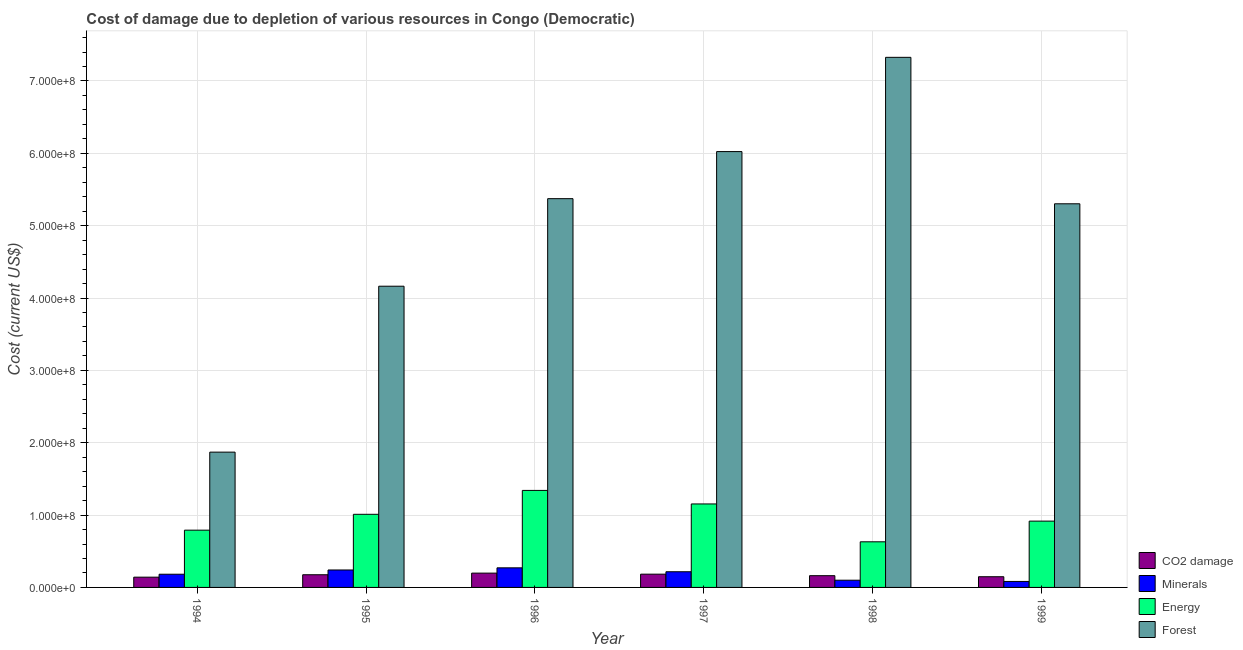How many different coloured bars are there?
Offer a very short reply. 4. Are the number of bars per tick equal to the number of legend labels?
Your response must be concise. Yes. Are the number of bars on each tick of the X-axis equal?
Give a very brief answer. Yes. How many bars are there on the 3rd tick from the left?
Your answer should be very brief. 4. How many bars are there on the 6th tick from the right?
Your response must be concise. 4. In how many cases, is the number of bars for a given year not equal to the number of legend labels?
Ensure brevity in your answer.  0. What is the cost of damage due to depletion of forests in 1999?
Ensure brevity in your answer.  5.30e+08. Across all years, what is the maximum cost of damage due to depletion of energy?
Make the answer very short. 1.34e+08. Across all years, what is the minimum cost of damage due to depletion of forests?
Your response must be concise. 1.87e+08. In which year was the cost of damage due to depletion of minerals maximum?
Ensure brevity in your answer.  1996. What is the total cost of damage due to depletion of minerals in the graph?
Your answer should be compact. 1.09e+08. What is the difference between the cost of damage due to depletion of minerals in 1996 and that in 1999?
Offer a terse response. 1.88e+07. What is the difference between the cost of damage due to depletion of coal in 1995 and the cost of damage due to depletion of energy in 1994?
Ensure brevity in your answer.  3.35e+06. What is the average cost of damage due to depletion of forests per year?
Offer a terse response. 5.01e+08. In how many years, is the cost of damage due to depletion of forests greater than 680000000 US$?
Give a very brief answer. 1. What is the ratio of the cost of damage due to depletion of coal in 1997 to that in 1999?
Offer a very short reply. 1.24. Is the cost of damage due to depletion of forests in 1994 less than that in 1995?
Keep it short and to the point. Yes. What is the difference between the highest and the second highest cost of damage due to depletion of minerals?
Make the answer very short. 2.97e+06. What is the difference between the highest and the lowest cost of damage due to depletion of minerals?
Give a very brief answer. 1.88e+07. In how many years, is the cost of damage due to depletion of energy greater than the average cost of damage due to depletion of energy taken over all years?
Ensure brevity in your answer.  3. What does the 3rd bar from the left in 1996 represents?
Offer a terse response. Energy. What does the 4th bar from the right in 1995 represents?
Give a very brief answer. CO2 damage. Where does the legend appear in the graph?
Make the answer very short. Bottom right. What is the title of the graph?
Give a very brief answer. Cost of damage due to depletion of various resources in Congo (Democratic) . Does "PFC gas" appear as one of the legend labels in the graph?
Keep it short and to the point. No. What is the label or title of the Y-axis?
Provide a succinct answer. Cost (current US$). What is the Cost (current US$) in CO2 damage in 1994?
Provide a short and direct response. 1.42e+07. What is the Cost (current US$) in Minerals in 1994?
Provide a succinct answer. 1.82e+07. What is the Cost (current US$) of Energy in 1994?
Give a very brief answer. 7.91e+07. What is the Cost (current US$) of Forest in 1994?
Provide a succinct answer. 1.87e+08. What is the Cost (current US$) of CO2 damage in 1995?
Your response must be concise. 1.75e+07. What is the Cost (current US$) in Minerals in 1995?
Provide a short and direct response. 2.41e+07. What is the Cost (current US$) of Energy in 1995?
Your answer should be very brief. 1.01e+08. What is the Cost (current US$) in Forest in 1995?
Keep it short and to the point. 4.16e+08. What is the Cost (current US$) of CO2 damage in 1996?
Give a very brief answer. 1.98e+07. What is the Cost (current US$) in Minerals in 1996?
Give a very brief answer. 2.71e+07. What is the Cost (current US$) of Energy in 1996?
Give a very brief answer. 1.34e+08. What is the Cost (current US$) of Forest in 1996?
Make the answer very short. 5.37e+08. What is the Cost (current US$) of CO2 damage in 1997?
Give a very brief answer. 1.83e+07. What is the Cost (current US$) in Minerals in 1997?
Provide a short and direct response. 2.17e+07. What is the Cost (current US$) of Energy in 1997?
Offer a very short reply. 1.15e+08. What is the Cost (current US$) in Forest in 1997?
Ensure brevity in your answer.  6.02e+08. What is the Cost (current US$) in CO2 damage in 1998?
Offer a terse response. 1.62e+07. What is the Cost (current US$) in Minerals in 1998?
Make the answer very short. 9.97e+06. What is the Cost (current US$) of Energy in 1998?
Your answer should be very brief. 6.31e+07. What is the Cost (current US$) in Forest in 1998?
Your answer should be very brief. 7.33e+08. What is the Cost (current US$) in CO2 damage in 1999?
Give a very brief answer. 1.48e+07. What is the Cost (current US$) of Minerals in 1999?
Offer a very short reply. 8.26e+06. What is the Cost (current US$) in Energy in 1999?
Give a very brief answer. 9.16e+07. What is the Cost (current US$) of Forest in 1999?
Keep it short and to the point. 5.30e+08. Across all years, what is the maximum Cost (current US$) in CO2 damage?
Your response must be concise. 1.98e+07. Across all years, what is the maximum Cost (current US$) in Minerals?
Your response must be concise. 2.71e+07. Across all years, what is the maximum Cost (current US$) of Energy?
Give a very brief answer. 1.34e+08. Across all years, what is the maximum Cost (current US$) of Forest?
Your answer should be very brief. 7.33e+08. Across all years, what is the minimum Cost (current US$) in CO2 damage?
Offer a very short reply. 1.42e+07. Across all years, what is the minimum Cost (current US$) in Minerals?
Offer a terse response. 8.26e+06. Across all years, what is the minimum Cost (current US$) of Energy?
Keep it short and to the point. 6.31e+07. Across all years, what is the minimum Cost (current US$) in Forest?
Provide a short and direct response. 1.87e+08. What is the total Cost (current US$) of CO2 damage in the graph?
Provide a short and direct response. 1.01e+08. What is the total Cost (current US$) in Minerals in the graph?
Keep it short and to the point. 1.09e+08. What is the total Cost (current US$) of Energy in the graph?
Make the answer very short. 5.84e+08. What is the total Cost (current US$) of Forest in the graph?
Provide a succinct answer. 3.01e+09. What is the difference between the Cost (current US$) in CO2 damage in 1994 and that in 1995?
Give a very brief answer. -3.35e+06. What is the difference between the Cost (current US$) of Minerals in 1994 and that in 1995?
Your answer should be compact. -5.87e+06. What is the difference between the Cost (current US$) of Energy in 1994 and that in 1995?
Provide a succinct answer. -2.19e+07. What is the difference between the Cost (current US$) of Forest in 1994 and that in 1995?
Provide a short and direct response. -2.29e+08. What is the difference between the Cost (current US$) in CO2 damage in 1994 and that in 1996?
Provide a short and direct response. -5.60e+06. What is the difference between the Cost (current US$) of Minerals in 1994 and that in 1996?
Offer a very short reply. -8.84e+06. What is the difference between the Cost (current US$) in Energy in 1994 and that in 1996?
Your answer should be compact. -5.49e+07. What is the difference between the Cost (current US$) of Forest in 1994 and that in 1996?
Keep it short and to the point. -3.50e+08. What is the difference between the Cost (current US$) of CO2 damage in 1994 and that in 1997?
Ensure brevity in your answer.  -4.15e+06. What is the difference between the Cost (current US$) of Minerals in 1994 and that in 1997?
Your response must be concise. -3.42e+06. What is the difference between the Cost (current US$) of Energy in 1994 and that in 1997?
Your response must be concise. -3.62e+07. What is the difference between the Cost (current US$) of Forest in 1994 and that in 1997?
Provide a short and direct response. -4.15e+08. What is the difference between the Cost (current US$) in CO2 damage in 1994 and that in 1998?
Make the answer very short. -2.05e+06. What is the difference between the Cost (current US$) in Minerals in 1994 and that in 1998?
Provide a succinct answer. 8.28e+06. What is the difference between the Cost (current US$) of Energy in 1994 and that in 1998?
Keep it short and to the point. 1.61e+07. What is the difference between the Cost (current US$) of Forest in 1994 and that in 1998?
Ensure brevity in your answer.  -5.46e+08. What is the difference between the Cost (current US$) of CO2 damage in 1994 and that in 1999?
Offer a very short reply. -6.12e+05. What is the difference between the Cost (current US$) in Minerals in 1994 and that in 1999?
Keep it short and to the point. 9.99e+06. What is the difference between the Cost (current US$) of Energy in 1994 and that in 1999?
Provide a short and direct response. -1.25e+07. What is the difference between the Cost (current US$) of Forest in 1994 and that in 1999?
Provide a succinct answer. -3.43e+08. What is the difference between the Cost (current US$) of CO2 damage in 1995 and that in 1996?
Offer a terse response. -2.25e+06. What is the difference between the Cost (current US$) in Minerals in 1995 and that in 1996?
Provide a short and direct response. -2.97e+06. What is the difference between the Cost (current US$) of Energy in 1995 and that in 1996?
Make the answer very short. -3.30e+07. What is the difference between the Cost (current US$) of Forest in 1995 and that in 1996?
Offer a terse response. -1.21e+08. What is the difference between the Cost (current US$) in CO2 damage in 1995 and that in 1997?
Offer a terse response. -8.02e+05. What is the difference between the Cost (current US$) of Minerals in 1995 and that in 1997?
Offer a very short reply. 2.44e+06. What is the difference between the Cost (current US$) in Energy in 1995 and that in 1997?
Give a very brief answer. -1.43e+07. What is the difference between the Cost (current US$) of Forest in 1995 and that in 1997?
Provide a succinct answer. -1.86e+08. What is the difference between the Cost (current US$) in CO2 damage in 1995 and that in 1998?
Give a very brief answer. 1.30e+06. What is the difference between the Cost (current US$) in Minerals in 1995 and that in 1998?
Offer a very short reply. 1.41e+07. What is the difference between the Cost (current US$) in Energy in 1995 and that in 1998?
Your answer should be compact. 3.80e+07. What is the difference between the Cost (current US$) in Forest in 1995 and that in 1998?
Your answer should be compact. -3.16e+08. What is the difference between the Cost (current US$) of CO2 damage in 1995 and that in 1999?
Make the answer very short. 2.74e+06. What is the difference between the Cost (current US$) in Minerals in 1995 and that in 1999?
Your answer should be very brief. 1.59e+07. What is the difference between the Cost (current US$) in Energy in 1995 and that in 1999?
Offer a very short reply. 9.42e+06. What is the difference between the Cost (current US$) in Forest in 1995 and that in 1999?
Your answer should be compact. -1.14e+08. What is the difference between the Cost (current US$) of CO2 damage in 1996 and that in 1997?
Make the answer very short. 1.45e+06. What is the difference between the Cost (current US$) in Minerals in 1996 and that in 1997?
Ensure brevity in your answer.  5.42e+06. What is the difference between the Cost (current US$) of Energy in 1996 and that in 1997?
Keep it short and to the point. 1.87e+07. What is the difference between the Cost (current US$) in Forest in 1996 and that in 1997?
Your response must be concise. -6.51e+07. What is the difference between the Cost (current US$) in CO2 damage in 1996 and that in 1998?
Provide a short and direct response. 3.54e+06. What is the difference between the Cost (current US$) of Minerals in 1996 and that in 1998?
Your answer should be very brief. 1.71e+07. What is the difference between the Cost (current US$) in Energy in 1996 and that in 1998?
Keep it short and to the point. 7.10e+07. What is the difference between the Cost (current US$) of Forest in 1996 and that in 1998?
Provide a succinct answer. -1.95e+08. What is the difference between the Cost (current US$) in CO2 damage in 1996 and that in 1999?
Your answer should be very brief. 4.98e+06. What is the difference between the Cost (current US$) in Minerals in 1996 and that in 1999?
Give a very brief answer. 1.88e+07. What is the difference between the Cost (current US$) of Energy in 1996 and that in 1999?
Ensure brevity in your answer.  4.24e+07. What is the difference between the Cost (current US$) in Forest in 1996 and that in 1999?
Your response must be concise. 7.09e+06. What is the difference between the Cost (current US$) of CO2 damage in 1997 and that in 1998?
Ensure brevity in your answer.  2.10e+06. What is the difference between the Cost (current US$) of Minerals in 1997 and that in 1998?
Provide a short and direct response. 1.17e+07. What is the difference between the Cost (current US$) in Energy in 1997 and that in 1998?
Keep it short and to the point. 5.23e+07. What is the difference between the Cost (current US$) in Forest in 1997 and that in 1998?
Your answer should be very brief. -1.30e+08. What is the difference between the Cost (current US$) in CO2 damage in 1997 and that in 1999?
Ensure brevity in your answer.  3.54e+06. What is the difference between the Cost (current US$) of Minerals in 1997 and that in 1999?
Keep it short and to the point. 1.34e+07. What is the difference between the Cost (current US$) in Energy in 1997 and that in 1999?
Your response must be concise. 2.38e+07. What is the difference between the Cost (current US$) of Forest in 1997 and that in 1999?
Ensure brevity in your answer.  7.22e+07. What is the difference between the Cost (current US$) in CO2 damage in 1998 and that in 1999?
Make the answer very short. 1.44e+06. What is the difference between the Cost (current US$) of Minerals in 1998 and that in 1999?
Offer a terse response. 1.71e+06. What is the difference between the Cost (current US$) in Energy in 1998 and that in 1999?
Provide a succinct answer. -2.86e+07. What is the difference between the Cost (current US$) of Forest in 1998 and that in 1999?
Provide a short and direct response. 2.02e+08. What is the difference between the Cost (current US$) of CO2 damage in 1994 and the Cost (current US$) of Minerals in 1995?
Provide a succinct answer. -9.93e+06. What is the difference between the Cost (current US$) of CO2 damage in 1994 and the Cost (current US$) of Energy in 1995?
Offer a very short reply. -8.69e+07. What is the difference between the Cost (current US$) in CO2 damage in 1994 and the Cost (current US$) in Forest in 1995?
Your answer should be compact. -4.02e+08. What is the difference between the Cost (current US$) of Minerals in 1994 and the Cost (current US$) of Energy in 1995?
Offer a terse response. -8.28e+07. What is the difference between the Cost (current US$) in Minerals in 1994 and the Cost (current US$) in Forest in 1995?
Make the answer very short. -3.98e+08. What is the difference between the Cost (current US$) of Energy in 1994 and the Cost (current US$) of Forest in 1995?
Give a very brief answer. -3.37e+08. What is the difference between the Cost (current US$) of CO2 damage in 1994 and the Cost (current US$) of Minerals in 1996?
Your answer should be compact. -1.29e+07. What is the difference between the Cost (current US$) of CO2 damage in 1994 and the Cost (current US$) of Energy in 1996?
Provide a succinct answer. -1.20e+08. What is the difference between the Cost (current US$) in CO2 damage in 1994 and the Cost (current US$) in Forest in 1996?
Your response must be concise. -5.23e+08. What is the difference between the Cost (current US$) of Minerals in 1994 and the Cost (current US$) of Energy in 1996?
Keep it short and to the point. -1.16e+08. What is the difference between the Cost (current US$) of Minerals in 1994 and the Cost (current US$) of Forest in 1996?
Your answer should be compact. -5.19e+08. What is the difference between the Cost (current US$) in Energy in 1994 and the Cost (current US$) in Forest in 1996?
Your answer should be very brief. -4.58e+08. What is the difference between the Cost (current US$) of CO2 damage in 1994 and the Cost (current US$) of Minerals in 1997?
Provide a short and direct response. -7.49e+06. What is the difference between the Cost (current US$) of CO2 damage in 1994 and the Cost (current US$) of Energy in 1997?
Your answer should be very brief. -1.01e+08. What is the difference between the Cost (current US$) in CO2 damage in 1994 and the Cost (current US$) in Forest in 1997?
Make the answer very short. -5.88e+08. What is the difference between the Cost (current US$) in Minerals in 1994 and the Cost (current US$) in Energy in 1997?
Offer a terse response. -9.71e+07. What is the difference between the Cost (current US$) in Minerals in 1994 and the Cost (current US$) in Forest in 1997?
Ensure brevity in your answer.  -5.84e+08. What is the difference between the Cost (current US$) in Energy in 1994 and the Cost (current US$) in Forest in 1997?
Provide a succinct answer. -5.23e+08. What is the difference between the Cost (current US$) of CO2 damage in 1994 and the Cost (current US$) of Minerals in 1998?
Make the answer very short. 4.22e+06. What is the difference between the Cost (current US$) in CO2 damage in 1994 and the Cost (current US$) in Energy in 1998?
Ensure brevity in your answer.  -4.89e+07. What is the difference between the Cost (current US$) of CO2 damage in 1994 and the Cost (current US$) of Forest in 1998?
Offer a very short reply. -7.19e+08. What is the difference between the Cost (current US$) of Minerals in 1994 and the Cost (current US$) of Energy in 1998?
Keep it short and to the point. -4.48e+07. What is the difference between the Cost (current US$) of Minerals in 1994 and the Cost (current US$) of Forest in 1998?
Ensure brevity in your answer.  -7.14e+08. What is the difference between the Cost (current US$) in Energy in 1994 and the Cost (current US$) in Forest in 1998?
Provide a succinct answer. -6.54e+08. What is the difference between the Cost (current US$) in CO2 damage in 1994 and the Cost (current US$) in Minerals in 1999?
Offer a terse response. 5.92e+06. What is the difference between the Cost (current US$) in CO2 damage in 1994 and the Cost (current US$) in Energy in 1999?
Ensure brevity in your answer.  -7.75e+07. What is the difference between the Cost (current US$) in CO2 damage in 1994 and the Cost (current US$) in Forest in 1999?
Your response must be concise. -5.16e+08. What is the difference between the Cost (current US$) of Minerals in 1994 and the Cost (current US$) of Energy in 1999?
Provide a short and direct response. -7.34e+07. What is the difference between the Cost (current US$) in Minerals in 1994 and the Cost (current US$) in Forest in 1999?
Your response must be concise. -5.12e+08. What is the difference between the Cost (current US$) of Energy in 1994 and the Cost (current US$) of Forest in 1999?
Make the answer very short. -4.51e+08. What is the difference between the Cost (current US$) of CO2 damage in 1995 and the Cost (current US$) of Minerals in 1996?
Your answer should be compact. -9.56e+06. What is the difference between the Cost (current US$) of CO2 damage in 1995 and the Cost (current US$) of Energy in 1996?
Provide a succinct answer. -1.17e+08. What is the difference between the Cost (current US$) in CO2 damage in 1995 and the Cost (current US$) in Forest in 1996?
Offer a very short reply. -5.20e+08. What is the difference between the Cost (current US$) in Minerals in 1995 and the Cost (current US$) in Energy in 1996?
Your answer should be very brief. -1.10e+08. What is the difference between the Cost (current US$) in Minerals in 1995 and the Cost (current US$) in Forest in 1996?
Offer a very short reply. -5.13e+08. What is the difference between the Cost (current US$) in Energy in 1995 and the Cost (current US$) in Forest in 1996?
Keep it short and to the point. -4.36e+08. What is the difference between the Cost (current US$) of CO2 damage in 1995 and the Cost (current US$) of Minerals in 1997?
Your response must be concise. -4.14e+06. What is the difference between the Cost (current US$) in CO2 damage in 1995 and the Cost (current US$) in Energy in 1997?
Give a very brief answer. -9.79e+07. What is the difference between the Cost (current US$) of CO2 damage in 1995 and the Cost (current US$) of Forest in 1997?
Offer a very short reply. -5.85e+08. What is the difference between the Cost (current US$) in Minerals in 1995 and the Cost (current US$) in Energy in 1997?
Keep it short and to the point. -9.13e+07. What is the difference between the Cost (current US$) in Minerals in 1995 and the Cost (current US$) in Forest in 1997?
Give a very brief answer. -5.78e+08. What is the difference between the Cost (current US$) in Energy in 1995 and the Cost (current US$) in Forest in 1997?
Keep it short and to the point. -5.01e+08. What is the difference between the Cost (current US$) of CO2 damage in 1995 and the Cost (current US$) of Minerals in 1998?
Your answer should be compact. 7.56e+06. What is the difference between the Cost (current US$) in CO2 damage in 1995 and the Cost (current US$) in Energy in 1998?
Provide a short and direct response. -4.55e+07. What is the difference between the Cost (current US$) of CO2 damage in 1995 and the Cost (current US$) of Forest in 1998?
Your response must be concise. -7.15e+08. What is the difference between the Cost (current US$) in Minerals in 1995 and the Cost (current US$) in Energy in 1998?
Make the answer very short. -3.89e+07. What is the difference between the Cost (current US$) in Minerals in 1995 and the Cost (current US$) in Forest in 1998?
Your answer should be compact. -7.09e+08. What is the difference between the Cost (current US$) of Energy in 1995 and the Cost (current US$) of Forest in 1998?
Provide a short and direct response. -6.32e+08. What is the difference between the Cost (current US$) of CO2 damage in 1995 and the Cost (current US$) of Minerals in 1999?
Give a very brief answer. 9.27e+06. What is the difference between the Cost (current US$) of CO2 damage in 1995 and the Cost (current US$) of Energy in 1999?
Give a very brief answer. -7.41e+07. What is the difference between the Cost (current US$) in CO2 damage in 1995 and the Cost (current US$) in Forest in 1999?
Give a very brief answer. -5.13e+08. What is the difference between the Cost (current US$) of Minerals in 1995 and the Cost (current US$) of Energy in 1999?
Provide a short and direct response. -6.75e+07. What is the difference between the Cost (current US$) of Minerals in 1995 and the Cost (current US$) of Forest in 1999?
Ensure brevity in your answer.  -5.06e+08. What is the difference between the Cost (current US$) in Energy in 1995 and the Cost (current US$) in Forest in 1999?
Your answer should be very brief. -4.29e+08. What is the difference between the Cost (current US$) of CO2 damage in 1996 and the Cost (current US$) of Minerals in 1997?
Provide a succinct answer. -1.89e+06. What is the difference between the Cost (current US$) of CO2 damage in 1996 and the Cost (current US$) of Energy in 1997?
Ensure brevity in your answer.  -9.56e+07. What is the difference between the Cost (current US$) in CO2 damage in 1996 and the Cost (current US$) in Forest in 1997?
Offer a very short reply. -5.83e+08. What is the difference between the Cost (current US$) in Minerals in 1996 and the Cost (current US$) in Energy in 1997?
Provide a succinct answer. -8.83e+07. What is the difference between the Cost (current US$) in Minerals in 1996 and the Cost (current US$) in Forest in 1997?
Offer a very short reply. -5.75e+08. What is the difference between the Cost (current US$) of Energy in 1996 and the Cost (current US$) of Forest in 1997?
Provide a succinct answer. -4.68e+08. What is the difference between the Cost (current US$) of CO2 damage in 1996 and the Cost (current US$) of Minerals in 1998?
Give a very brief answer. 9.81e+06. What is the difference between the Cost (current US$) of CO2 damage in 1996 and the Cost (current US$) of Energy in 1998?
Provide a succinct answer. -4.33e+07. What is the difference between the Cost (current US$) in CO2 damage in 1996 and the Cost (current US$) in Forest in 1998?
Your answer should be very brief. -7.13e+08. What is the difference between the Cost (current US$) in Minerals in 1996 and the Cost (current US$) in Energy in 1998?
Ensure brevity in your answer.  -3.60e+07. What is the difference between the Cost (current US$) of Minerals in 1996 and the Cost (current US$) of Forest in 1998?
Offer a terse response. -7.06e+08. What is the difference between the Cost (current US$) of Energy in 1996 and the Cost (current US$) of Forest in 1998?
Provide a succinct answer. -5.99e+08. What is the difference between the Cost (current US$) of CO2 damage in 1996 and the Cost (current US$) of Minerals in 1999?
Your answer should be compact. 1.15e+07. What is the difference between the Cost (current US$) in CO2 damage in 1996 and the Cost (current US$) in Energy in 1999?
Your answer should be very brief. -7.19e+07. What is the difference between the Cost (current US$) in CO2 damage in 1996 and the Cost (current US$) in Forest in 1999?
Make the answer very short. -5.10e+08. What is the difference between the Cost (current US$) in Minerals in 1996 and the Cost (current US$) in Energy in 1999?
Make the answer very short. -6.46e+07. What is the difference between the Cost (current US$) in Minerals in 1996 and the Cost (current US$) in Forest in 1999?
Give a very brief answer. -5.03e+08. What is the difference between the Cost (current US$) of Energy in 1996 and the Cost (current US$) of Forest in 1999?
Provide a short and direct response. -3.96e+08. What is the difference between the Cost (current US$) in CO2 damage in 1997 and the Cost (current US$) in Minerals in 1998?
Ensure brevity in your answer.  8.37e+06. What is the difference between the Cost (current US$) of CO2 damage in 1997 and the Cost (current US$) of Energy in 1998?
Your answer should be compact. -4.47e+07. What is the difference between the Cost (current US$) in CO2 damage in 1997 and the Cost (current US$) in Forest in 1998?
Keep it short and to the point. -7.14e+08. What is the difference between the Cost (current US$) of Minerals in 1997 and the Cost (current US$) of Energy in 1998?
Give a very brief answer. -4.14e+07. What is the difference between the Cost (current US$) of Minerals in 1997 and the Cost (current US$) of Forest in 1998?
Provide a short and direct response. -7.11e+08. What is the difference between the Cost (current US$) in Energy in 1997 and the Cost (current US$) in Forest in 1998?
Provide a short and direct response. -6.17e+08. What is the difference between the Cost (current US$) in CO2 damage in 1997 and the Cost (current US$) in Minerals in 1999?
Offer a terse response. 1.01e+07. What is the difference between the Cost (current US$) in CO2 damage in 1997 and the Cost (current US$) in Energy in 1999?
Keep it short and to the point. -7.33e+07. What is the difference between the Cost (current US$) of CO2 damage in 1997 and the Cost (current US$) of Forest in 1999?
Your answer should be compact. -5.12e+08. What is the difference between the Cost (current US$) of Minerals in 1997 and the Cost (current US$) of Energy in 1999?
Provide a succinct answer. -7.00e+07. What is the difference between the Cost (current US$) of Minerals in 1997 and the Cost (current US$) of Forest in 1999?
Keep it short and to the point. -5.09e+08. What is the difference between the Cost (current US$) in Energy in 1997 and the Cost (current US$) in Forest in 1999?
Offer a very short reply. -4.15e+08. What is the difference between the Cost (current US$) of CO2 damage in 1998 and the Cost (current US$) of Minerals in 1999?
Your response must be concise. 7.97e+06. What is the difference between the Cost (current US$) of CO2 damage in 1998 and the Cost (current US$) of Energy in 1999?
Your response must be concise. -7.54e+07. What is the difference between the Cost (current US$) of CO2 damage in 1998 and the Cost (current US$) of Forest in 1999?
Provide a succinct answer. -5.14e+08. What is the difference between the Cost (current US$) in Minerals in 1998 and the Cost (current US$) in Energy in 1999?
Your response must be concise. -8.17e+07. What is the difference between the Cost (current US$) in Minerals in 1998 and the Cost (current US$) in Forest in 1999?
Provide a succinct answer. -5.20e+08. What is the difference between the Cost (current US$) in Energy in 1998 and the Cost (current US$) in Forest in 1999?
Provide a succinct answer. -4.67e+08. What is the average Cost (current US$) of CO2 damage per year?
Your response must be concise. 1.68e+07. What is the average Cost (current US$) of Minerals per year?
Offer a terse response. 1.82e+07. What is the average Cost (current US$) in Energy per year?
Give a very brief answer. 9.74e+07. What is the average Cost (current US$) of Forest per year?
Provide a succinct answer. 5.01e+08. In the year 1994, what is the difference between the Cost (current US$) of CO2 damage and Cost (current US$) of Minerals?
Your answer should be compact. -4.06e+06. In the year 1994, what is the difference between the Cost (current US$) of CO2 damage and Cost (current US$) of Energy?
Give a very brief answer. -6.50e+07. In the year 1994, what is the difference between the Cost (current US$) in CO2 damage and Cost (current US$) in Forest?
Offer a very short reply. -1.73e+08. In the year 1994, what is the difference between the Cost (current US$) in Minerals and Cost (current US$) in Energy?
Your answer should be very brief. -6.09e+07. In the year 1994, what is the difference between the Cost (current US$) of Minerals and Cost (current US$) of Forest?
Offer a terse response. -1.69e+08. In the year 1994, what is the difference between the Cost (current US$) in Energy and Cost (current US$) in Forest?
Your answer should be very brief. -1.08e+08. In the year 1995, what is the difference between the Cost (current US$) of CO2 damage and Cost (current US$) of Minerals?
Offer a terse response. -6.58e+06. In the year 1995, what is the difference between the Cost (current US$) of CO2 damage and Cost (current US$) of Energy?
Make the answer very short. -8.35e+07. In the year 1995, what is the difference between the Cost (current US$) of CO2 damage and Cost (current US$) of Forest?
Your answer should be very brief. -3.99e+08. In the year 1995, what is the difference between the Cost (current US$) in Minerals and Cost (current US$) in Energy?
Offer a terse response. -7.70e+07. In the year 1995, what is the difference between the Cost (current US$) in Minerals and Cost (current US$) in Forest?
Ensure brevity in your answer.  -3.92e+08. In the year 1995, what is the difference between the Cost (current US$) of Energy and Cost (current US$) of Forest?
Provide a succinct answer. -3.15e+08. In the year 1996, what is the difference between the Cost (current US$) in CO2 damage and Cost (current US$) in Minerals?
Offer a terse response. -7.31e+06. In the year 1996, what is the difference between the Cost (current US$) of CO2 damage and Cost (current US$) of Energy?
Ensure brevity in your answer.  -1.14e+08. In the year 1996, what is the difference between the Cost (current US$) in CO2 damage and Cost (current US$) in Forest?
Ensure brevity in your answer.  -5.18e+08. In the year 1996, what is the difference between the Cost (current US$) in Minerals and Cost (current US$) in Energy?
Your answer should be very brief. -1.07e+08. In the year 1996, what is the difference between the Cost (current US$) in Minerals and Cost (current US$) in Forest?
Offer a terse response. -5.10e+08. In the year 1996, what is the difference between the Cost (current US$) of Energy and Cost (current US$) of Forest?
Provide a short and direct response. -4.03e+08. In the year 1997, what is the difference between the Cost (current US$) of CO2 damage and Cost (current US$) of Minerals?
Provide a short and direct response. -3.34e+06. In the year 1997, what is the difference between the Cost (current US$) in CO2 damage and Cost (current US$) in Energy?
Make the answer very short. -9.71e+07. In the year 1997, what is the difference between the Cost (current US$) in CO2 damage and Cost (current US$) in Forest?
Offer a very short reply. -5.84e+08. In the year 1997, what is the difference between the Cost (current US$) in Minerals and Cost (current US$) in Energy?
Ensure brevity in your answer.  -9.37e+07. In the year 1997, what is the difference between the Cost (current US$) of Minerals and Cost (current US$) of Forest?
Your answer should be compact. -5.81e+08. In the year 1997, what is the difference between the Cost (current US$) in Energy and Cost (current US$) in Forest?
Provide a short and direct response. -4.87e+08. In the year 1998, what is the difference between the Cost (current US$) of CO2 damage and Cost (current US$) of Minerals?
Provide a succinct answer. 6.27e+06. In the year 1998, what is the difference between the Cost (current US$) in CO2 damage and Cost (current US$) in Energy?
Keep it short and to the point. -4.68e+07. In the year 1998, what is the difference between the Cost (current US$) in CO2 damage and Cost (current US$) in Forest?
Provide a short and direct response. -7.16e+08. In the year 1998, what is the difference between the Cost (current US$) in Minerals and Cost (current US$) in Energy?
Offer a very short reply. -5.31e+07. In the year 1998, what is the difference between the Cost (current US$) in Minerals and Cost (current US$) in Forest?
Provide a short and direct response. -7.23e+08. In the year 1998, what is the difference between the Cost (current US$) of Energy and Cost (current US$) of Forest?
Make the answer very short. -6.70e+08. In the year 1999, what is the difference between the Cost (current US$) in CO2 damage and Cost (current US$) in Minerals?
Offer a terse response. 6.53e+06. In the year 1999, what is the difference between the Cost (current US$) in CO2 damage and Cost (current US$) in Energy?
Ensure brevity in your answer.  -7.68e+07. In the year 1999, what is the difference between the Cost (current US$) in CO2 damage and Cost (current US$) in Forest?
Offer a very short reply. -5.15e+08. In the year 1999, what is the difference between the Cost (current US$) of Minerals and Cost (current US$) of Energy?
Your response must be concise. -8.34e+07. In the year 1999, what is the difference between the Cost (current US$) in Minerals and Cost (current US$) in Forest?
Make the answer very short. -5.22e+08. In the year 1999, what is the difference between the Cost (current US$) of Energy and Cost (current US$) of Forest?
Your response must be concise. -4.39e+08. What is the ratio of the Cost (current US$) of CO2 damage in 1994 to that in 1995?
Provide a succinct answer. 0.81. What is the ratio of the Cost (current US$) of Minerals in 1994 to that in 1995?
Your answer should be very brief. 0.76. What is the ratio of the Cost (current US$) in Energy in 1994 to that in 1995?
Your response must be concise. 0.78. What is the ratio of the Cost (current US$) of Forest in 1994 to that in 1995?
Give a very brief answer. 0.45. What is the ratio of the Cost (current US$) in CO2 damage in 1994 to that in 1996?
Provide a succinct answer. 0.72. What is the ratio of the Cost (current US$) of Minerals in 1994 to that in 1996?
Your answer should be compact. 0.67. What is the ratio of the Cost (current US$) of Energy in 1994 to that in 1996?
Offer a terse response. 0.59. What is the ratio of the Cost (current US$) of Forest in 1994 to that in 1996?
Offer a terse response. 0.35. What is the ratio of the Cost (current US$) in CO2 damage in 1994 to that in 1997?
Make the answer very short. 0.77. What is the ratio of the Cost (current US$) in Minerals in 1994 to that in 1997?
Your answer should be compact. 0.84. What is the ratio of the Cost (current US$) of Energy in 1994 to that in 1997?
Offer a very short reply. 0.69. What is the ratio of the Cost (current US$) of Forest in 1994 to that in 1997?
Your answer should be compact. 0.31. What is the ratio of the Cost (current US$) in CO2 damage in 1994 to that in 1998?
Provide a short and direct response. 0.87. What is the ratio of the Cost (current US$) of Minerals in 1994 to that in 1998?
Give a very brief answer. 1.83. What is the ratio of the Cost (current US$) of Energy in 1994 to that in 1998?
Provide a short and direct response. 1.26. What is the ratio of the Cost (current US$) in Forest in 1994 to that in 1998?
Offer a terse response. 0.26. What is the ratio of the Cost (current US$) in CO2 damage in 1994 to that in 1999?
Your answer should be compact. 0.96. What is the ratio of the Cost (current US$) of Minerals in 1994 to that in 1999?
Your response must be concise. 2.21. What is the ratio of the Cost (current US$) of Energy in 1994 to that in 1999?
Offer a very short reply. 0.86. What is the ratio of the Cost (current US$) in Forest in 1994 to that in 1999?
Provide a succinct answer. 0.35. What is the ratio of the Cost (current US$) of CO2 damage in 1995 to that in 1996?
Offer a very short reply. 0.89. What is the ratio of the Cost (current US$) in Minerals in 1995 to that in 1996?
Your answer should be very brief. 0.89. What is the ratio of the Cost (current US$) in Energy in 1995 to that in 1996?
Your response must be concise. 0.75. What is the ratio of the Cost (current US$) of Forest in 1995 to that in 1996?
Offer a very short reply. 0.77. What is the ratio of the Cost (current US$) in CO2 damage in 1995 to that in 1997?
Offer a very short reply. 0.96. What is the ratio of the Cost (current US$) in Minerals in 1995 to that in 1997?
Provide a succinct answer. 1.11. What is the ratio of the Cost (current US$) in Energy in 1995 to that in 1997?
Offer a terse response. 0.88. What is the ratio of the Cost (current US$) in Forest in 1995 to that in 1997?
Provide a short and direct response. 0.69. What is the ratio of the Cost (current US$) in CO2 damage in 1995 to that in 1998?
Provide a succinct answer. 1.08. What is the ratio of the Cost (current US$) of Minerals in 1995 to that in 1998?
Offer a very short reply. 2.42. What is the ratio of the Cost (current US$) in Energy in 1995 to that in 1998?
Keep it short and to the point. 1.6. What is the ratio of the Cost (current US$) of Forest in 1995 to that in 1998?
Offer a very short reply. 0.57. What is the ratio of the Cost (current US$) in CO2 damage in 1995 to that in 1999?
Offer a terse response. 1.18. What is the ratio of the Cost (current US$) of Minerals in 1995 to that in 1999?
Provide a short and direct response. 2.92. What is the ratio of the Cost (current US$) of Energy in 1995 to that in 1999?
Offer a terse response. 1.1. What is the ratio of the Cost (current US$) of Forest in 1995 to that in 1999?
Your response must be concise. 0.79. What is the ratio of the Cost (current US$) in CO2 damage in 1996 to that in 1997?
Provide a succinct answer. 1.08. What is the ratio of the Cost (current US$) of Minerals in 1996 to that in 1997?
Offer a terse response. 1.25. What is the ratio of the Cost (current US$) in Energy in 1996 to that in 1997?
Offer a terse response. 1.16. What is the ratio of the Cost (current US$) of Forest in 1996 to that in 1997?
Your answer should be very brief. 0.89. What is the ratio of the Cost (current US$) of CO2 damage in 1996 to that in 1998?
Provide a short and direct response. 1.22. What is the ratio of the Cost (current US$) in Minerals in 1996 to that in 1998?
Provide a short and direct response. 2.72. What is the ratio of the Cost (current US$) in Energy in 1996 to that in 1998?
Offer a terse response. 2.13. What is the ratio of the Cost (current US$) of Forest in 1996 to that in 1998?
Your answer should be very brief. 0.73. What is the ratio of the Cost (current US$) in CO2 damage in 1996 to that in 1999?
Provide a short and direct response. 1.34. What is the ratio of the Cost (current US$) in Minerals in 1996 to that in 1999?
Your answer should be very brief. 3.28. What is the ratio of the Cost (current US$) in Energy in 1996 to that in 1999?
Your response must be concise. 1.46. What is the ratio of the Cost (current US$) in Forest in 1996 to that in 1999?
Provide a short and direct response. 1.01. What is the ratio of the Cost (current US$) in CO2 damage in 1997 to that in 1998?
Give a very brief answer. 1.13. What is the ratio of the Cost (current US$) in Minerals in 1997 to that in 1998?
Your answer should be very brief. 2.17. What is the ratio of the Cost (current US$) of Energy in 1997 to that in 1998?
Ensure brevity in your answer.  1.83. What is the ratio of the Cost (current US$) of Forest in 1997 to that in 1998?
Offer a very short reply. 0.82. What is the ratio of the Cost (current US$) of CO2 damage in 1997 to that in 1999?
Provide a succinct answer. 1.24. What is the ratio of the Cost (current US$) in Minerals in 1997 to that in 1999?
Give a very brief answer. 2.62. What is the ratio of the Cost (current US$) in Energy in 1997 to that in 1999?
Offer a very short reply. 1.26. What is the ratio of the Cost (current US$) in Forest in 1997 to that in 1999?
Your answer should be compact. 1.14. What is the ratio of the Cost (current US$) in CO2 damage in 1998 to that in 1999?
Keep it short and to the point. 1.1. What is the ratio of the Cost (current US$) in Minerals in 1998 to that in 1999?
Ensure brevity in your answer.  1.21. What is the ratio of the Cost (current US$) of Energy in 1998 to that in 1999?
Keep it short and to the point. 0.69. What is the ratio of the Cost (current US$) of Forest in 1998 to that in 1999?
Give a very brief answer. 1.38. What is the difference between the highest and the second highest Cost (current US$) of CO2 damage?
Provide a succinct answer. 1.45e+06. What is the difference between the highest and the second highest Cost (current US$) of Minerals?
Make the answer very short. 2.97e+06. What is the difference between the highest and the second highest Cost (current US$) in Energy?
Your response must be concise. 1.87e+07. What is the difference between the highest and the second highest Cost (current US$) in Forest?
Your answer should be compact. 1.30e+08. What is the difference between the highest and the lowest Cost (current US$) of CO2 damage?
Give a very brief answer. 5.60e+06. What is the difference between the highest and the lowest Cost (current US$) of Minerals?
Make the answer very short. 1.88e+07. What is the difference between the highest and the lowest Cost (current US$) in Energy?
Offer a very short reply. 7.10e+07. What is the difference between the highest and the lowest Cost (current US$) in Forest?
Give a very brief answer. 5.46e+08. 